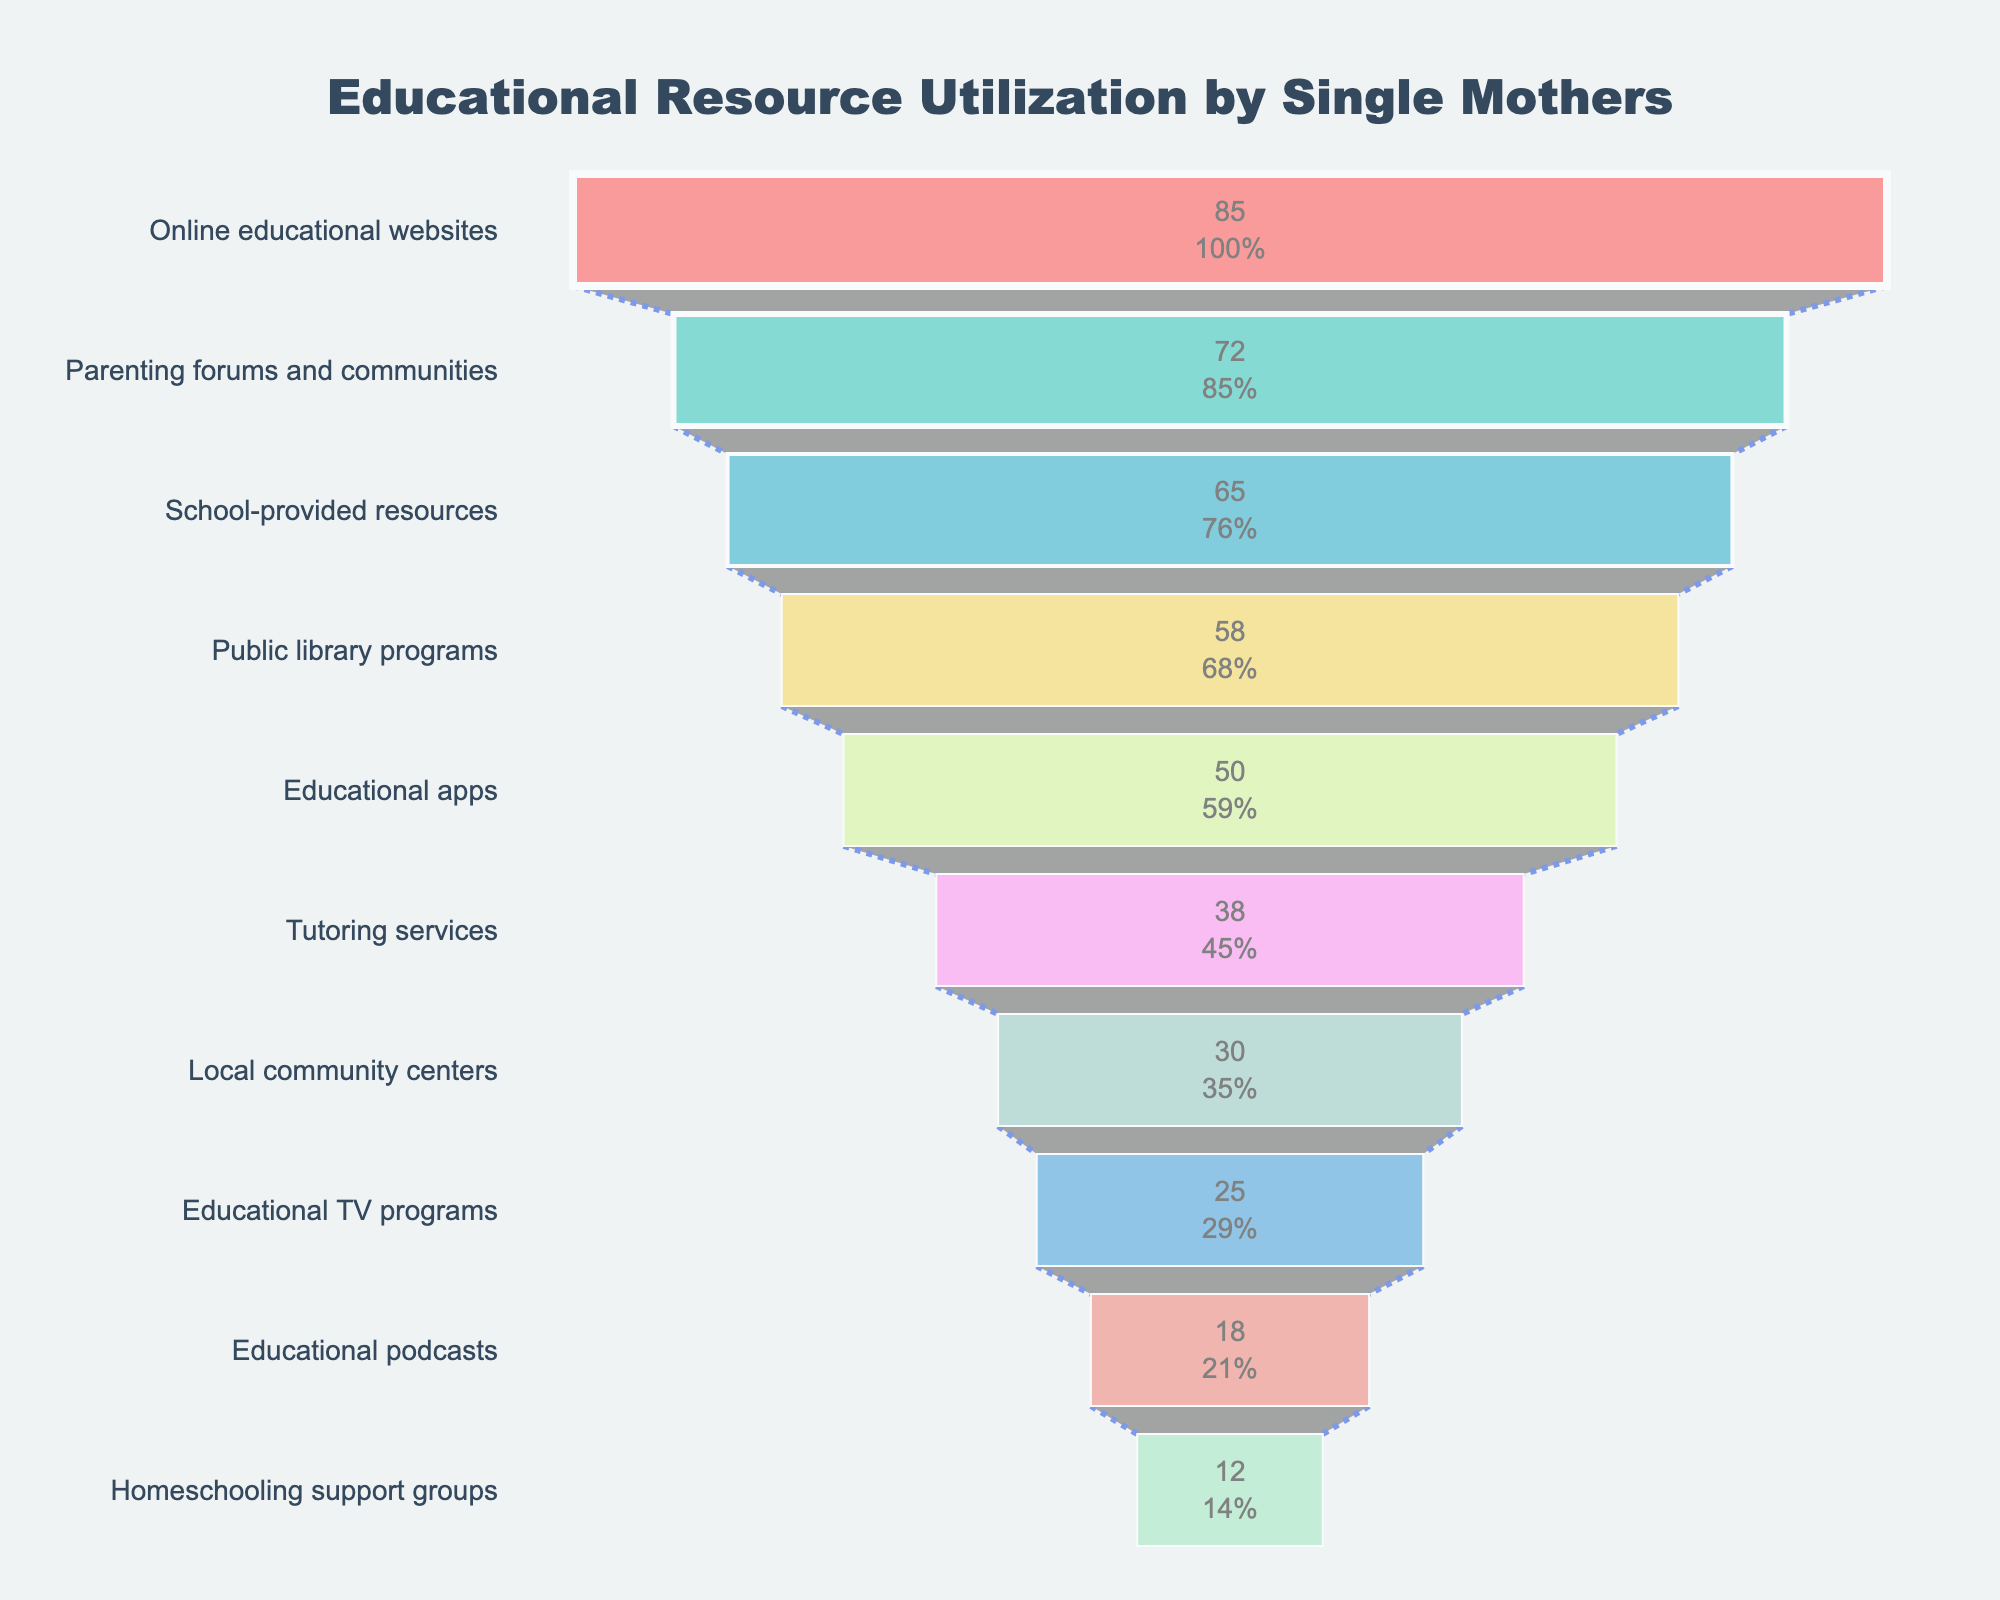What's the most used educational resource among single mothers? According to the funnel chart, the top-most segment represents the most used resource, which is "Online educational websites" with 85%.
Answer: Online educational websites What percentage of single mothers use tutoring services? From the funnel chart, find the segment labeled "Tutoring services" and note the percentage inside it, which is 38%.
Answer: 38% How much more popular are online educational websites compared to homeschooling support groups? Subtract the percentage of homeschooling support groups (12%) from the percentage of online educational websites (85%). That gives 85% - 12% = 73%.
Answer: 73% Which resource is used less, local community centers or educational TV programs? Locate both segments in the funnel chart; "Local community centers" shows 30%, and "Educational TV programs" shows 25%. Since 25% is less than 30%, educational TV programs are used less.
Answer: Educational TV programs What resource utilization sees exactly 50% of single mothers using it? Check the funnel chart for the segment labeled with 50%, which corresponds to "Educational apps".
Answer: Educational apps How many resources are used by less than 50% of single mothers? Count the number of segments that have percentages below 50%. They are "Tutoring services" (38%), "Local community centers" (30%), "Educational TV programs" (25%), "Educational podcasts" (18%), and "Homeschooling support groups" (12%). This totals to 5 resources.
Answer: 5 By how much do parenting forums and communities surpass educational TV programs in utilization? Subtract the percentage for educational TV programs (25%) from the percentage for parenting forums and communities (72%). So, 72% - 25% = 47%.
Answer: 47% Which educational resource is positioned directly below "Public library programs” in the funnel chart? Look at the segment following "Public library programs" (58%); it is "Educational apps" (50%).
Answer: Educational apps Are there more resources used by more than half of the single mothers or less? Count resources above 50%: Online educational websites (85%), Parenting forums and communities (72%), School-provided resources (65%), Public library programs (58%). That is 4 resources. Count resources below 50%: Educational apps (50%), Tutoring services (38%), Local community centers (30%), Educational TV programs (25%), Educational podcasts (18%), Homeschooling support groups (12%). That is 6 resources. Hence, more resources are used by less than 50%.
Answer: Less 